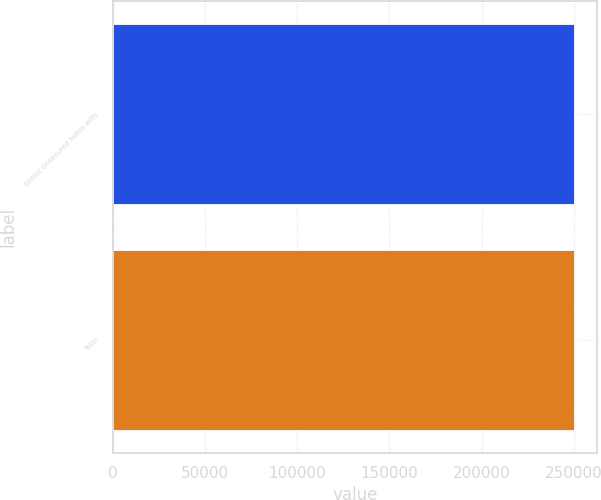<chart> <loc_0><loc_0><loc_500><loc_500><bar_chart><fcel>Senior Unsecured Notes with<fcel>Total<nl><fcel>250000<fcel>250000<nl></chart> 